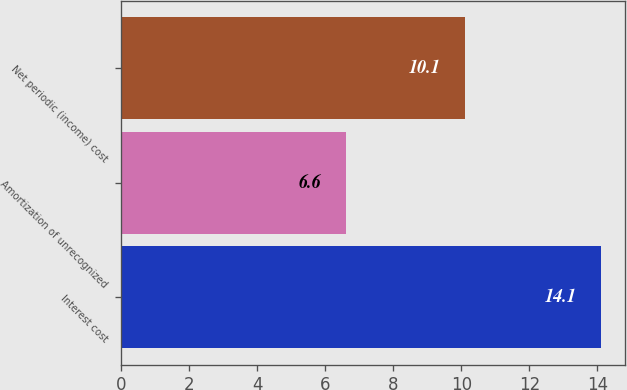<chart> <loc_0><loc_0><loc_500><loc_500><bar_chart><fcel>Interest cost<fcel>Amortization of unrecognized<fcel>Net periodic (income) cost<nl><fcel>14.1<fcel>6.6<fcel>10.1<nl></chart> 